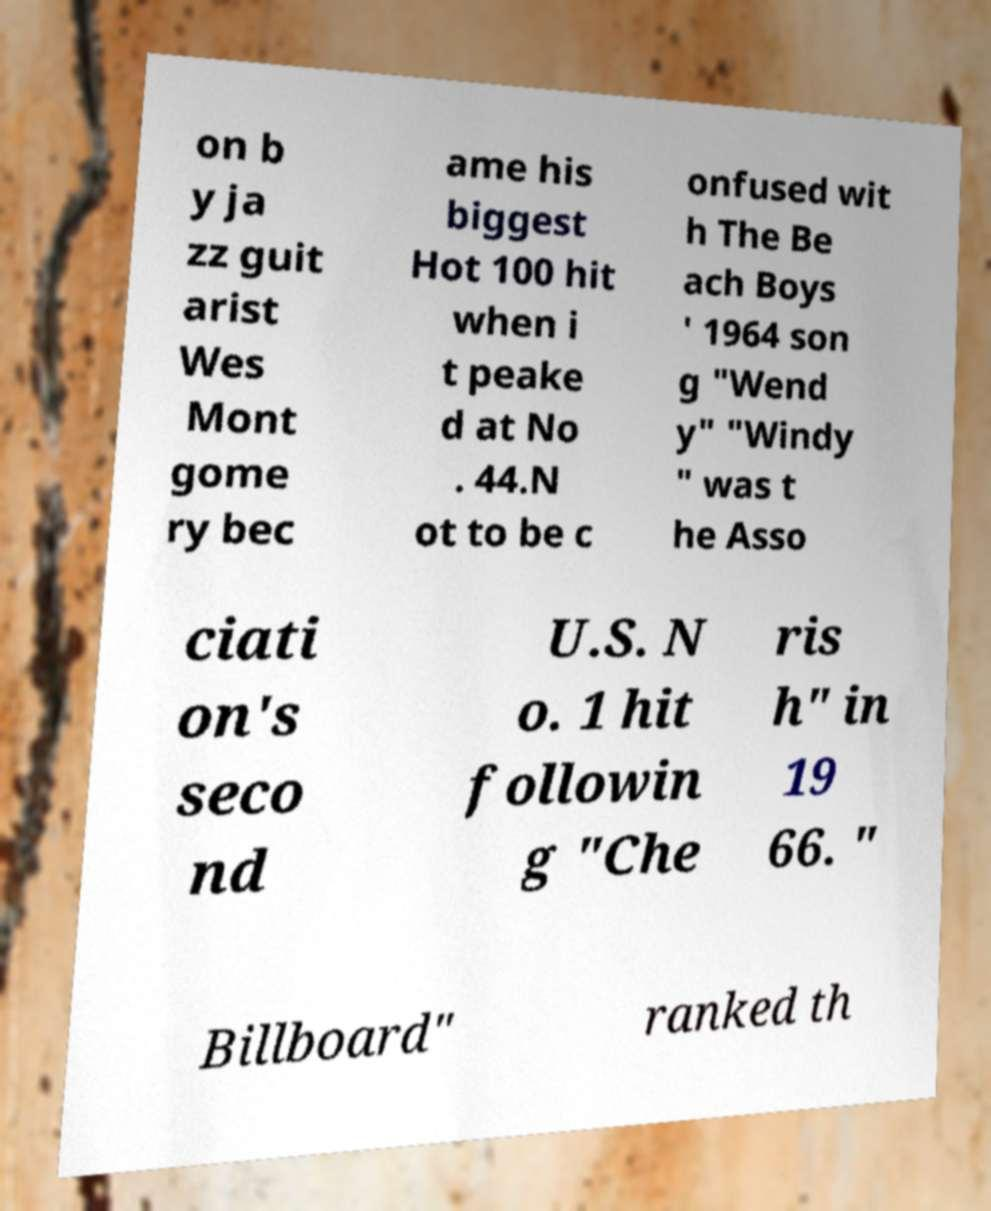What messages or text are displayed in this image? I need them in a readable, typed format. on b y ja zz guit arist Wes Mont gome ry bec ame his biggest Hot 100 hit when i t peake d at No . 44.N ot to be c onfused wit h The Be ach Boys ' 1964 son g "Wend y" "Windy " was t he Asso ciati on's seco nd U.S. N o. 1 hit followin g "Che ris h" in 19 66. " Billboard" ranked th 